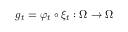Convert formula to latex. <formula><loc_0><loc_0><loc_500><loc_500>g _ { t } = \varphi _ { t } \circ \xi _ { t } \colon \Omega \to \Omega</formula> 